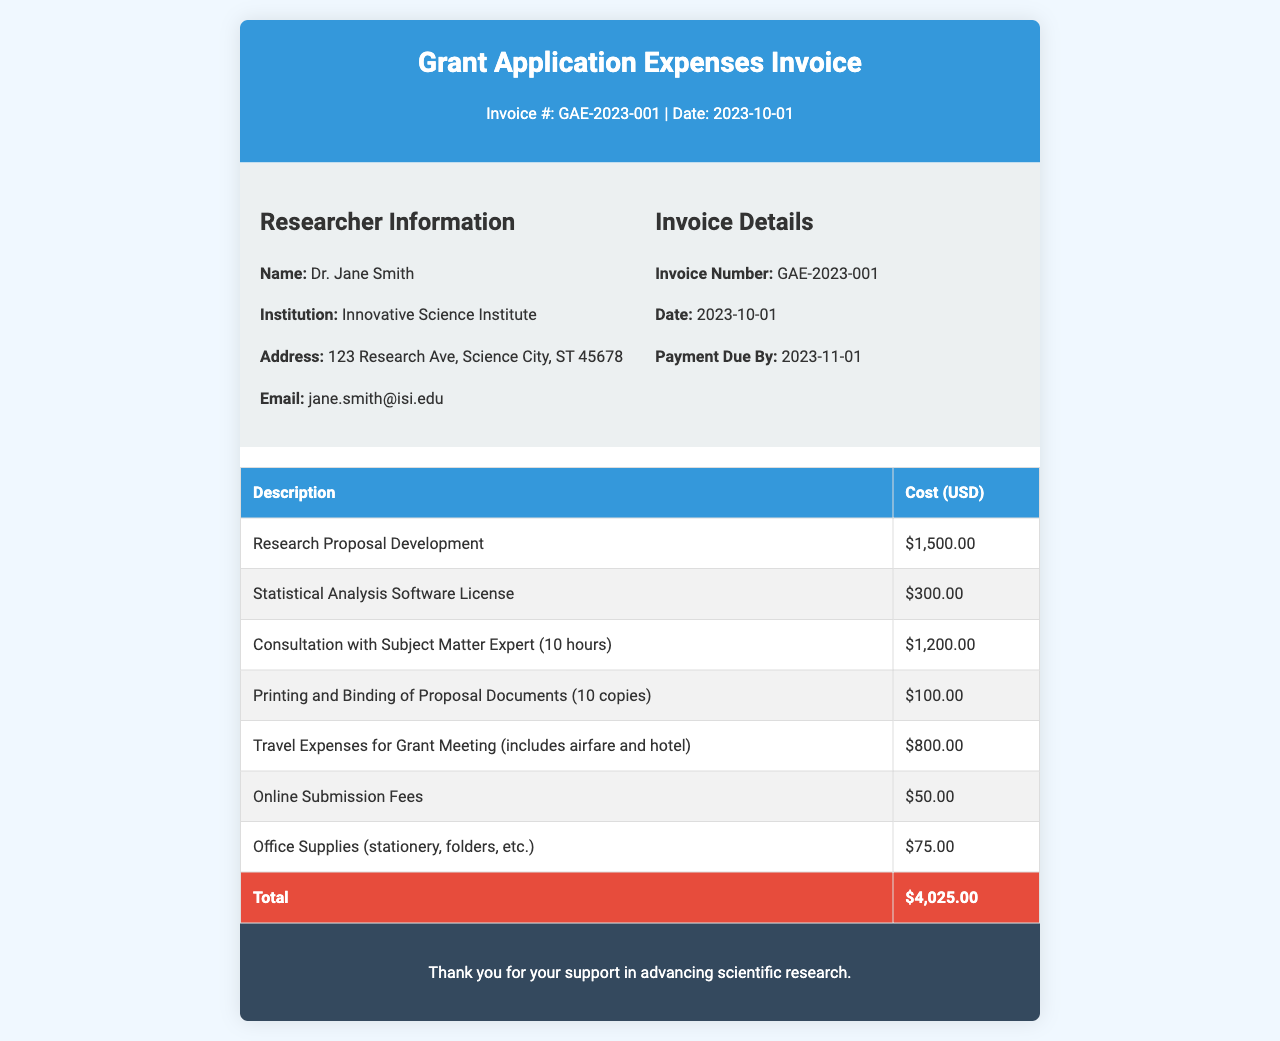What is the invoice number? The invoice number is clearly stated in the document header as GAE-2023-001.
Answer: GAE-2023-001 Who is the researcher? The researcher's name is provided in the researcher information section of the document as Dr. Jane Smith.
Answer: Dr. Jane Smith What is the total cost of the expenses? The total cost is indicated at the bottom of the expenses table as $4,025.00.
Answer: $4,025.00 What is the due date for payment? The payment due date is mentioned in the invoice details as 2023-11-01.
Answer: 2023-11-01 How much did the consultation with the subject matter expert cost? The cost for consultation is listed in the expenses table as $1,200.00.
Answer: $1,200.00 What item had the lowest cost? The item with the lowest cost is Online Submission Fees priced at $50.00, as seen in the expenses table.
Answer: $50.00 How many copies of proposal documents were printed and bound? The document states that 10 copies of proposal documents were printed and bound, found in the expenses table.
Answer: 10 copies What was included in the travel expenses? The travel expenses included airfare and hotel, as described under travel expenses in the expenses table.
Answer: airfare and hotel What institution is Dr. Jane Smith affiliated with? The document identifies Dr. Jane Smith's institution as Innovative Science Institute in the researcher information section.
Answer: Innovative Science Institute 